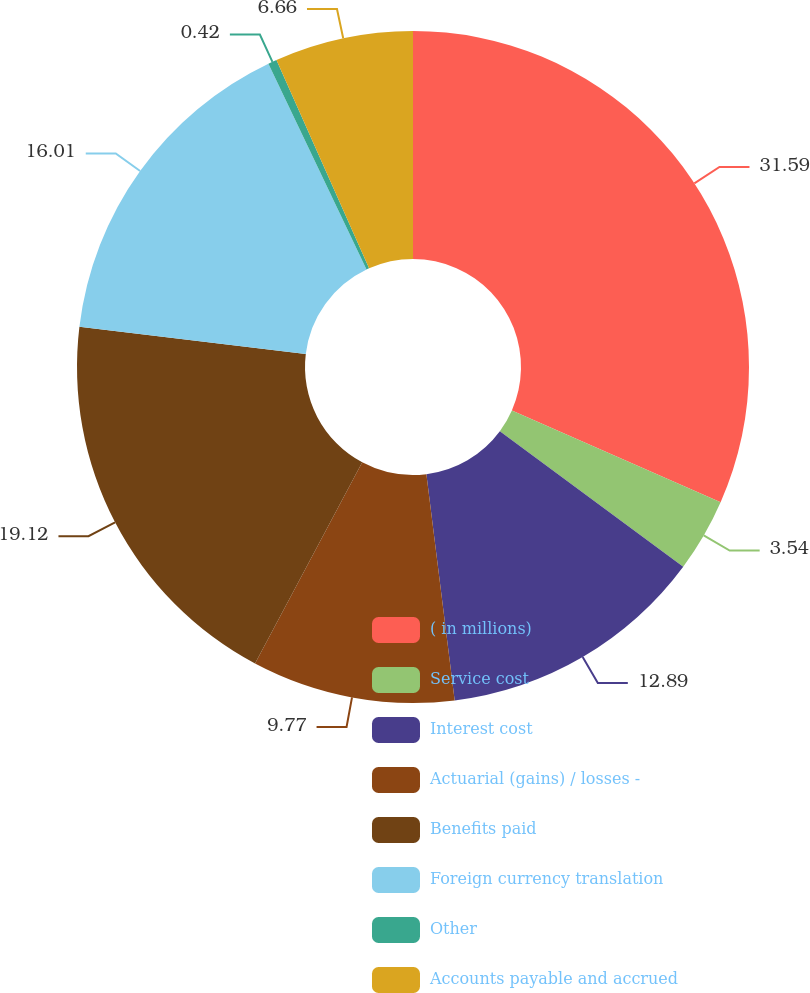Convert chart to OTSL. <chart><loc_0><loc_0><loc_500><loc_500><pie_chart><fcel>( in millions)<fcel>Service cost<fcel>Interest cost<fcel>Actuarial (gains) / losses -<fcel>Benefits paid<fcel>Foreign currency translation<fcel>Other<fcel>Accounts payable and accrued<nl><fcel>31.59%<fcel>3.54%<fcel>12.89%<fcel>9.77%<fcel>19.12%<fcel>16.01%<fcel>0.42%<fcel>6.66%<nl></chart> 